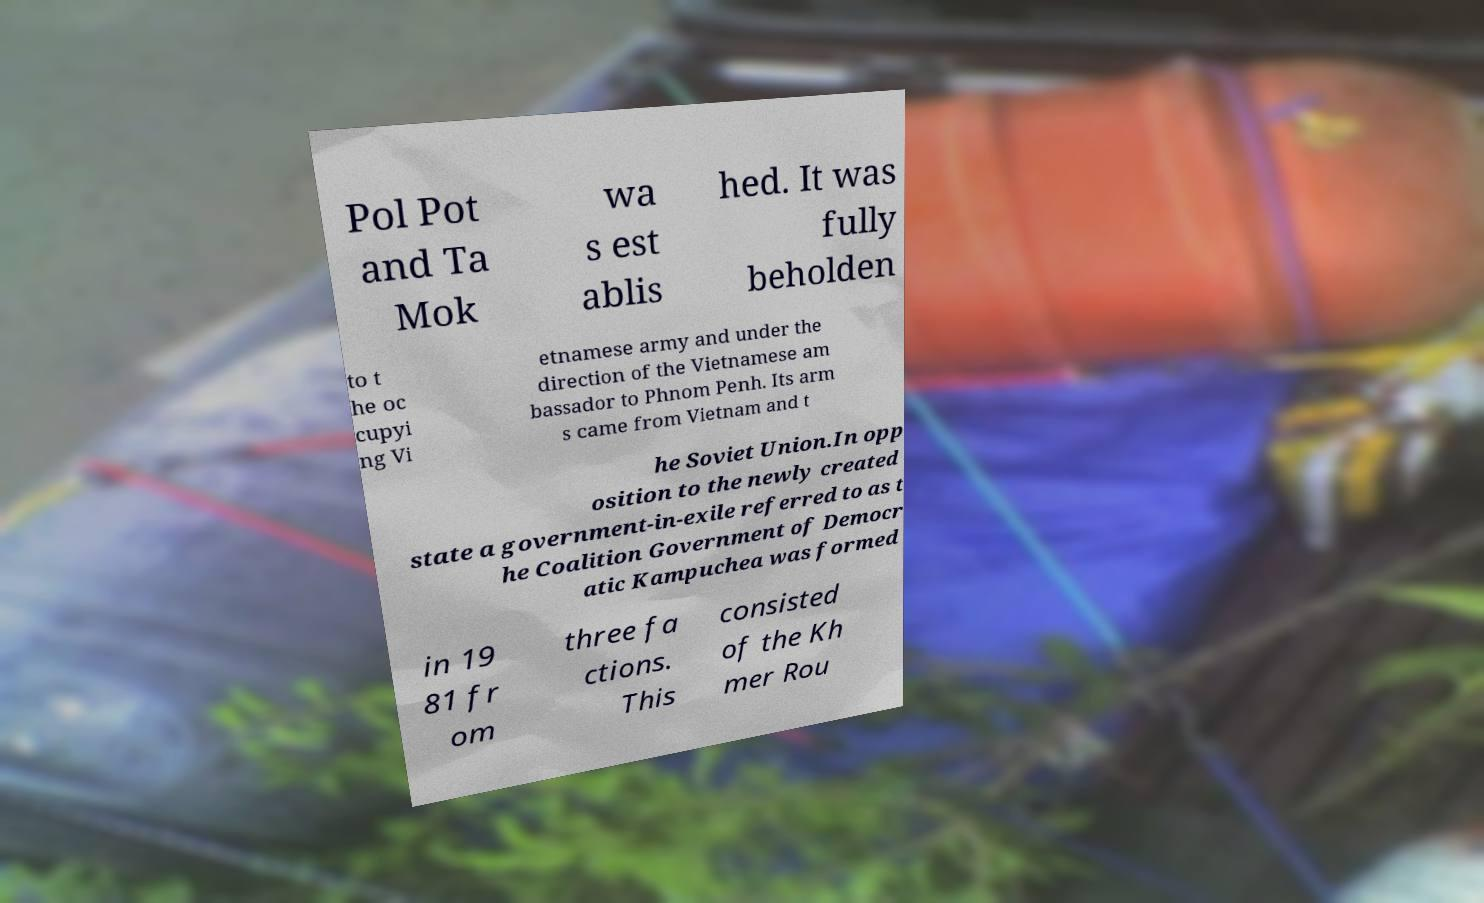Can you read and provide the text displayed in the image?This photo seems to have some interesting text. Can you extract and type it out for me? Pol Pot and Ta Mok wa s est ablis hed. It was fully beholden to t he oc cupyi ng Vi etnamese army and under the direction of the Vietnamese am bassador to Phnom Penh. Its arm s came from Vietnam and t he Soviet Union.In opp osition to the newly created state a government-in-exile referred to as t he Coalition Government of Democr atic Kampuchea was formed in 19 81 fr om three fa ctions. This consisted of the Kh mer Rou 